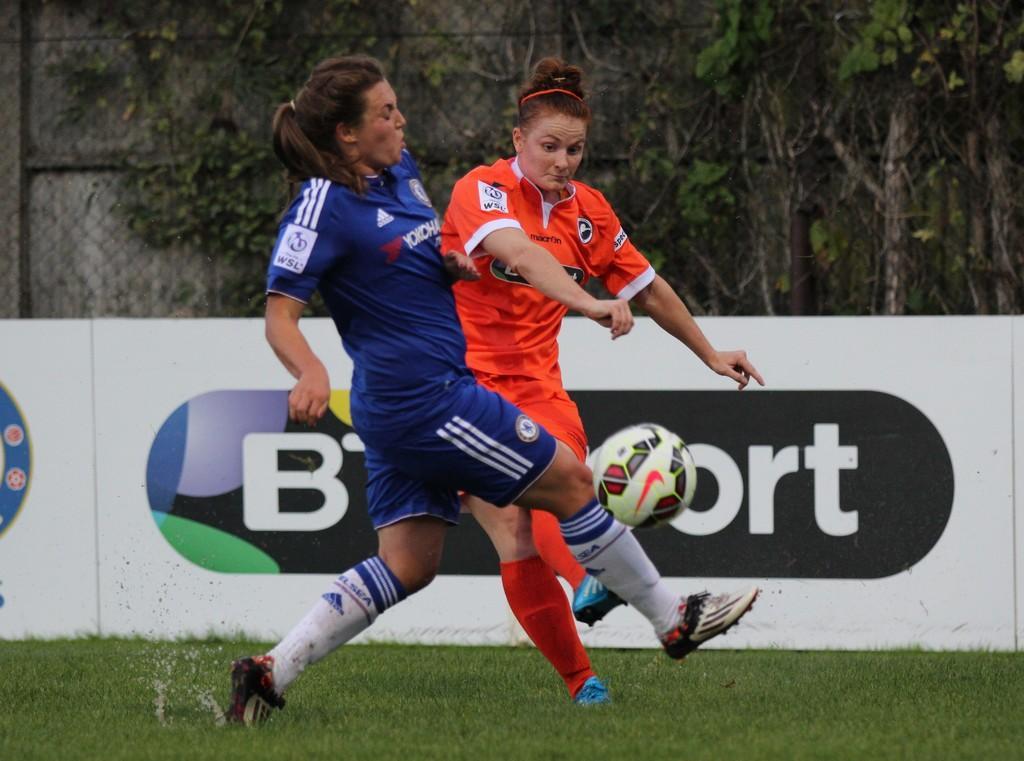Could you give a brief overview of what you see in this image? In the middle of this image, there are two women in violet and orange color dresses, playing football on the grass on the ground. In the background, there are two white color banners, there are trees and a wall. 